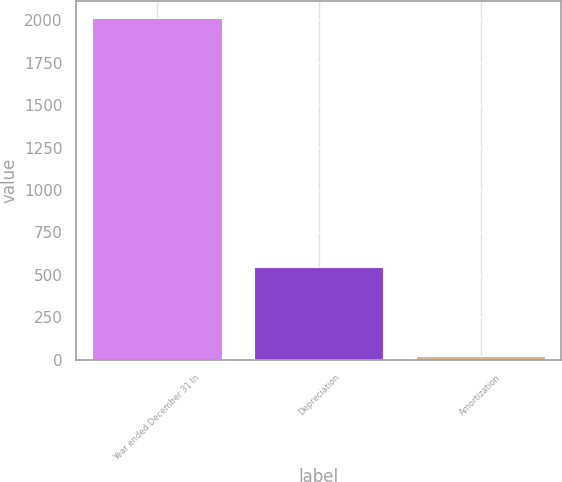Convert chart to OTSL. <chart><loc_0><loc_0><loc_500><loc_500><bar_chart><fcel>Year ended December 31 In<fcel>Depreciation<fcel>Amortization<nl><fcel>2013<fcel>546<fcel>23<nl></chart> 